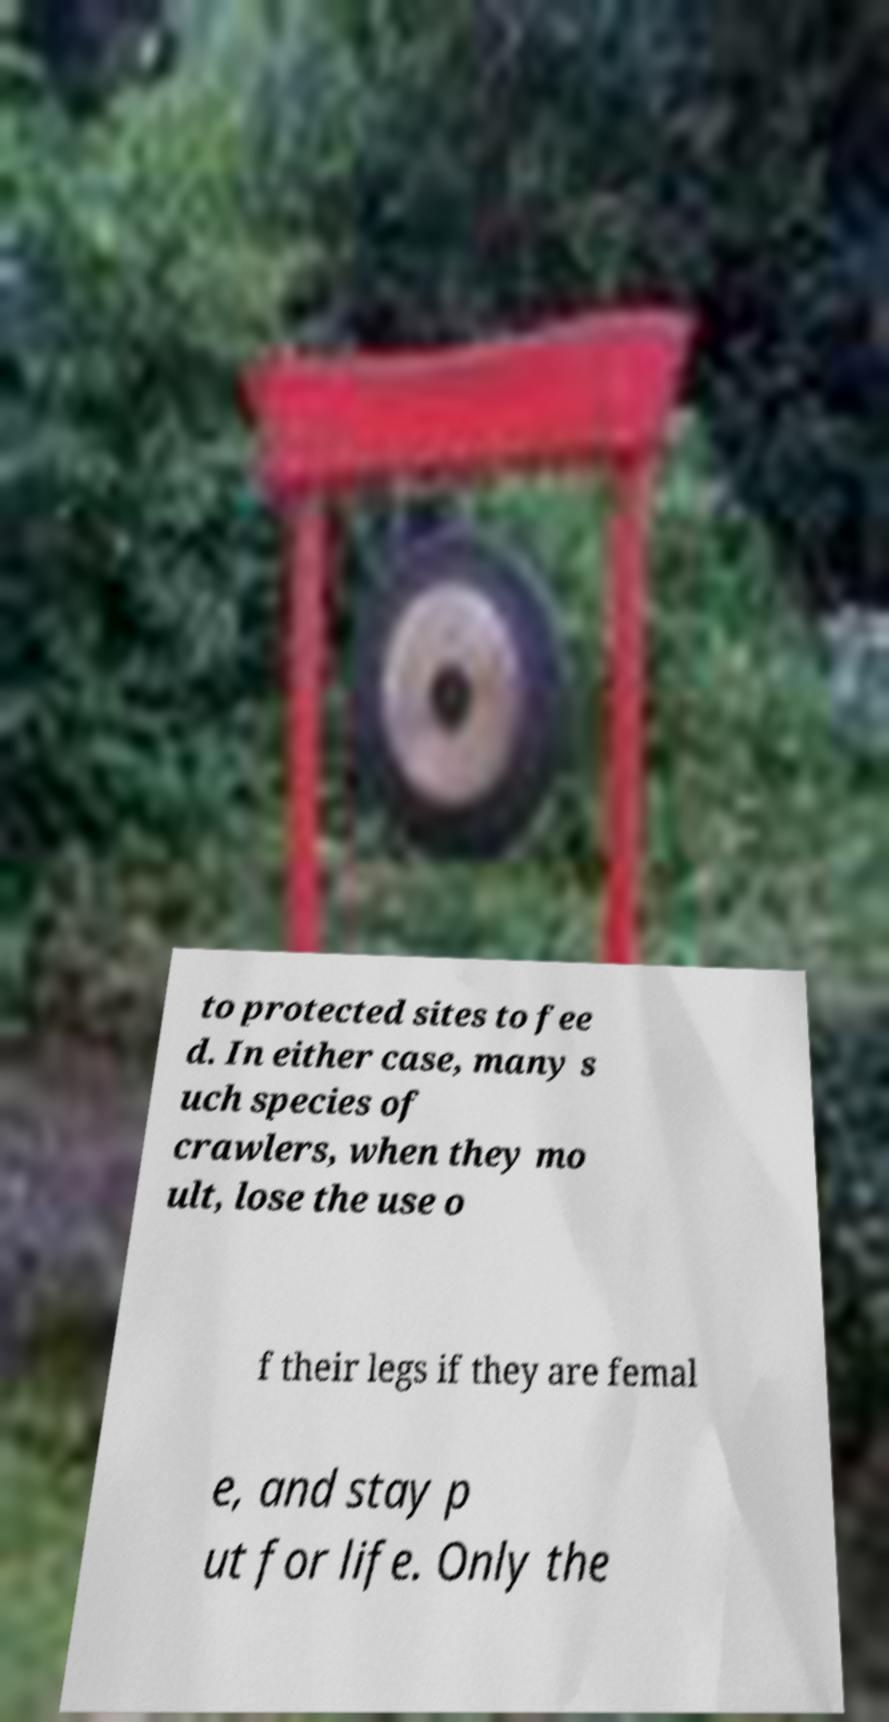I need the written content from this picture converted into text. Can you do that? to protected sites to fee d. In either case, many s uch species of crawlers, when they mo ult, lose the use o f their legs if they are femal e, and stay p ut for life. Only the 